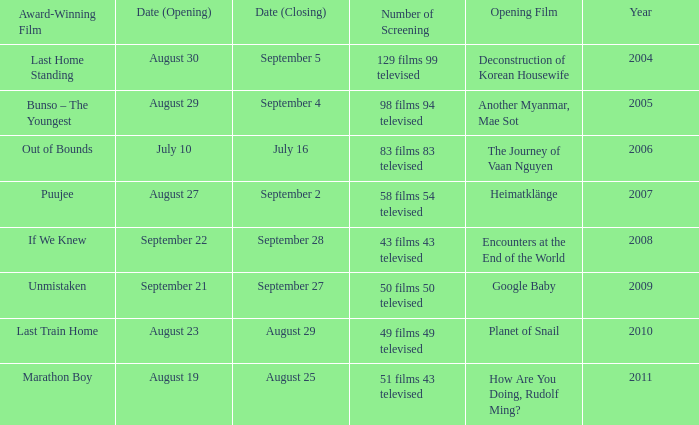Which opening film has the opening date of august 23? Planet of Snail. 